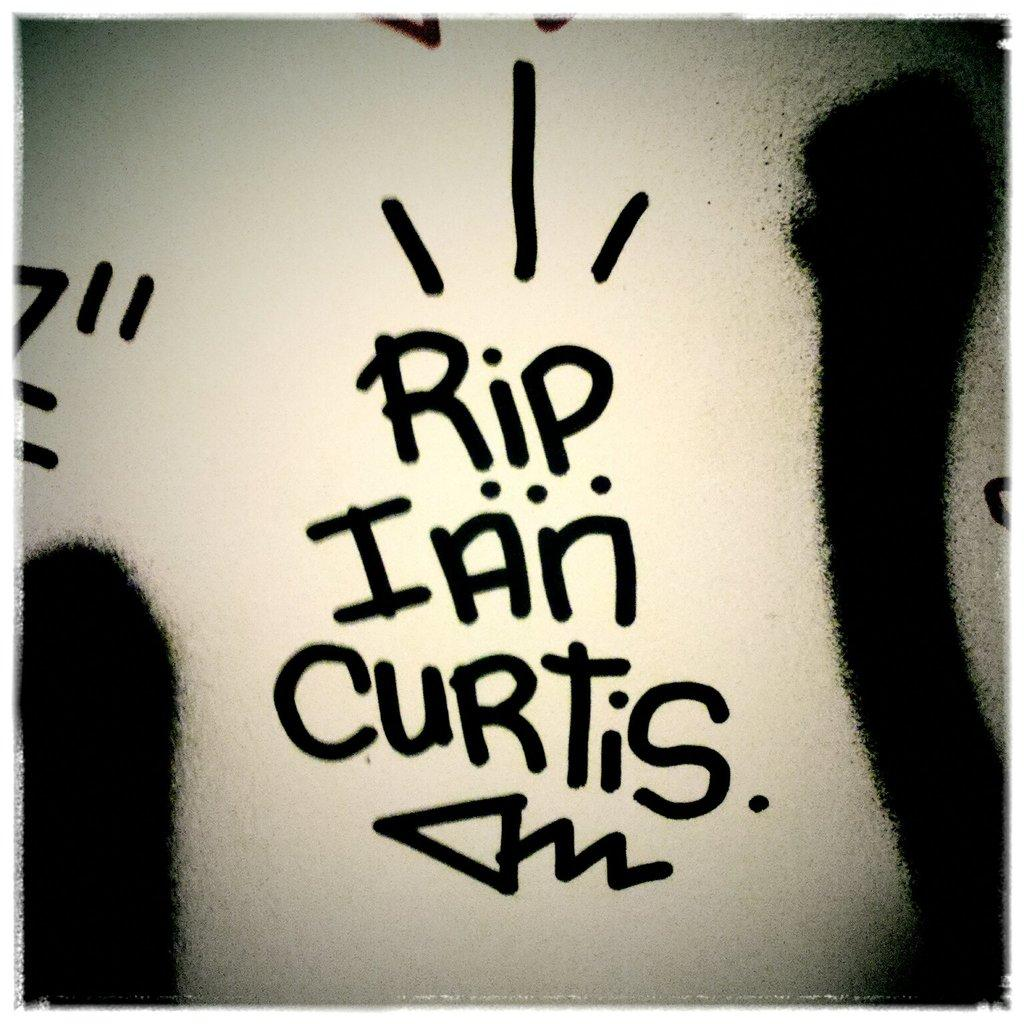<image>
Relay a brief, clear account of the picture shown. A wall has RIP Ian Curtis written on it. 